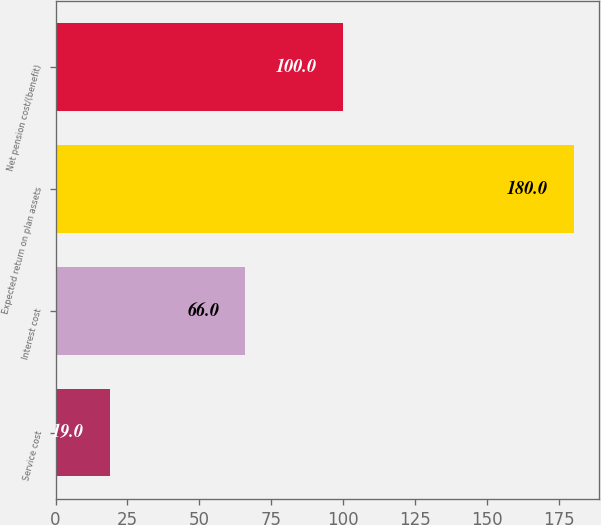<chart> <loc_0><loc_0><loc_500><loc_500><bar_chart><fcel>Service cost<fcel>Interest cost<fcel>Expected return on plan assets<fcel>Net pension cost/(benefit)<nl><fcel>19<fcel>66<fcel>180<fcel>100<nl></chart> 